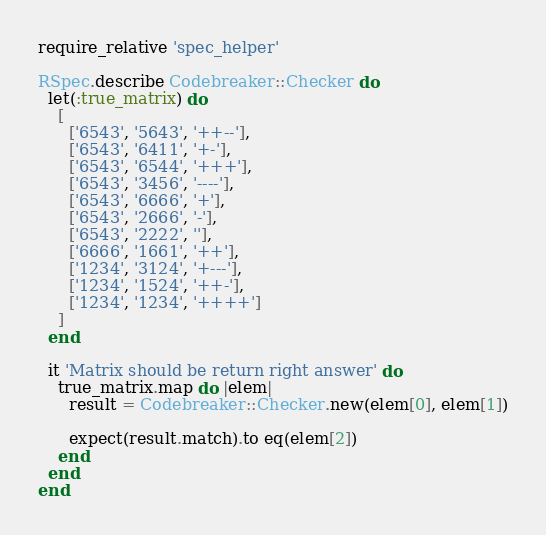<code> <loc_0><loc_0><loc_500><loc_500><_Ruby_>require_relative 'spec_helper'

RSpec.describe Codebreaker::Checker do
  let(:true_matrix) do
    [
      ['6543', '5643', '++--'],
      ['6543', '6411', '+-'],
      ['6543', '6544', '+++'],
      ['6543', '3456', '----'],
      ['6543', '6666', '+'],
      ['6543', '2666', '-'],
      ['6543', '2222', ''],
      ['6666', '1661', '++'],
      ['1234', '3124', '+---'],
      ['1234', '1524', '++-'],
      ['1234', '1234', '++++']
    ]
  end

  it 'Matrix should be return right answer' do
    true_matrix.map do |elem|
      result = Codebreaker::Checker.new(elem[0], elem[1])

      expect(result.match).to eq(elem[2])
    end
  end
end
</code> 